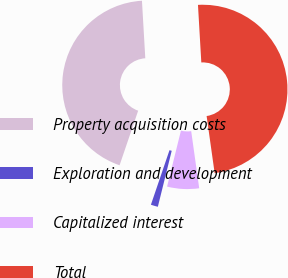<chart> <loc_0><loc_0><loc_500><loc_500><pie_chart><fcel>Property acquisition costs<fcel>Exploration and development<fcel>Capitalized interest<fcel>Total<nl><fcel>43.85%<fcel>1.36%<fcel>6.09%<fcel>48.7%<nl></chart> 